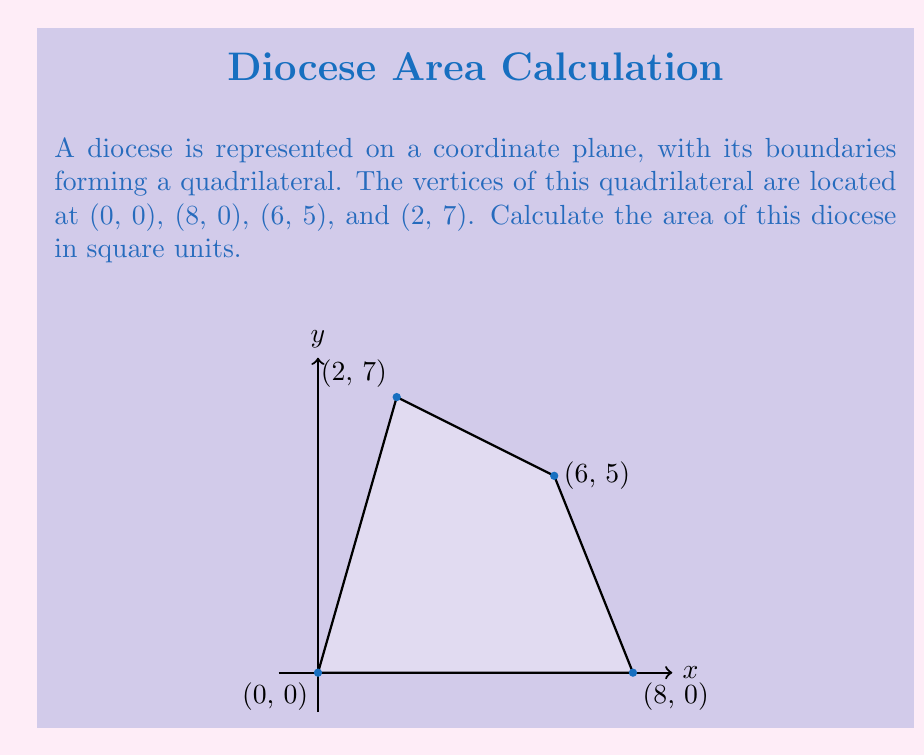Teach me how to tackle this problem. To calculate the area of this quadrilateral diocese, we can use the Shoelace formula (also known as the surveyor's formula). This method is particularly useful for calculating the area of a polygon given the coordinates of its vertices.

The Shoelace formula for a quadrilateral with vertices $(x_1, y_1)$, $(x_2, y_2)$, $(x_3, y_3)$, and $(x_4, y_4)$ is:

$$Area = \frac{1}{2}|(x_1y_2 + x_2y_3 + x_3y_4 + x_4y_1) - (y_1x_2 + y_2x_3 + y_3x_4 + y_4x_1)|$$

Let's plug in our coordinates:
$(x_1, y_1) = (0, 0)$
$(x_2, y_2) = (8, 0)$
$(x_3, y_3) = (6, 5)$
$(x_4, y_4) = (2, 7)$

Now, let's calculate:

$$\begin{align*}
Area &= \frac{1}{2}|((0 \cdot 0) + (8 \cdot 5) + (6 \cdot 7) + (2 \cdot 0)) - ((0 \cdot 8) + (0 \cdot 6) + (5 \cdot 2) + (7 \cdot 0))|\\
&= \frac{1}{2}|(0 + 40 + 42 + 0) - (0 + 0 + 10 + 0)|\\
&= \frac{1}{2}|82 - 10|\\
&= \frac{1}{2} \cdot 72\\
&= 36
\end{align*}$$

Therefore, the area of the diocese is 36 square units.
Answer: $36$ square units 